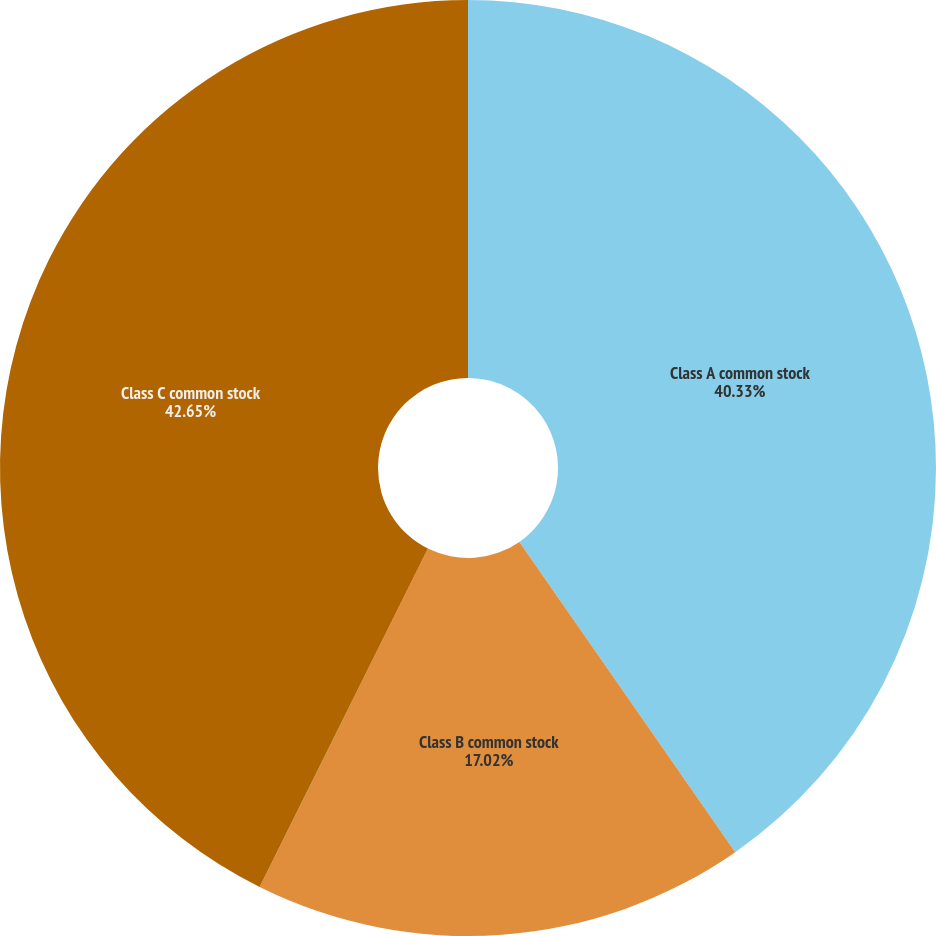Convert chart to OTSL. <chart><loc_0><loc_0><loc_500><loc_500><pie_chart><fcel>Class A common stock<fcel>Class B common stock<fcel>Class C common stock<nl><fcel>40.33%<fcel>17.02%<fcel>42.66%<nl></chart> 